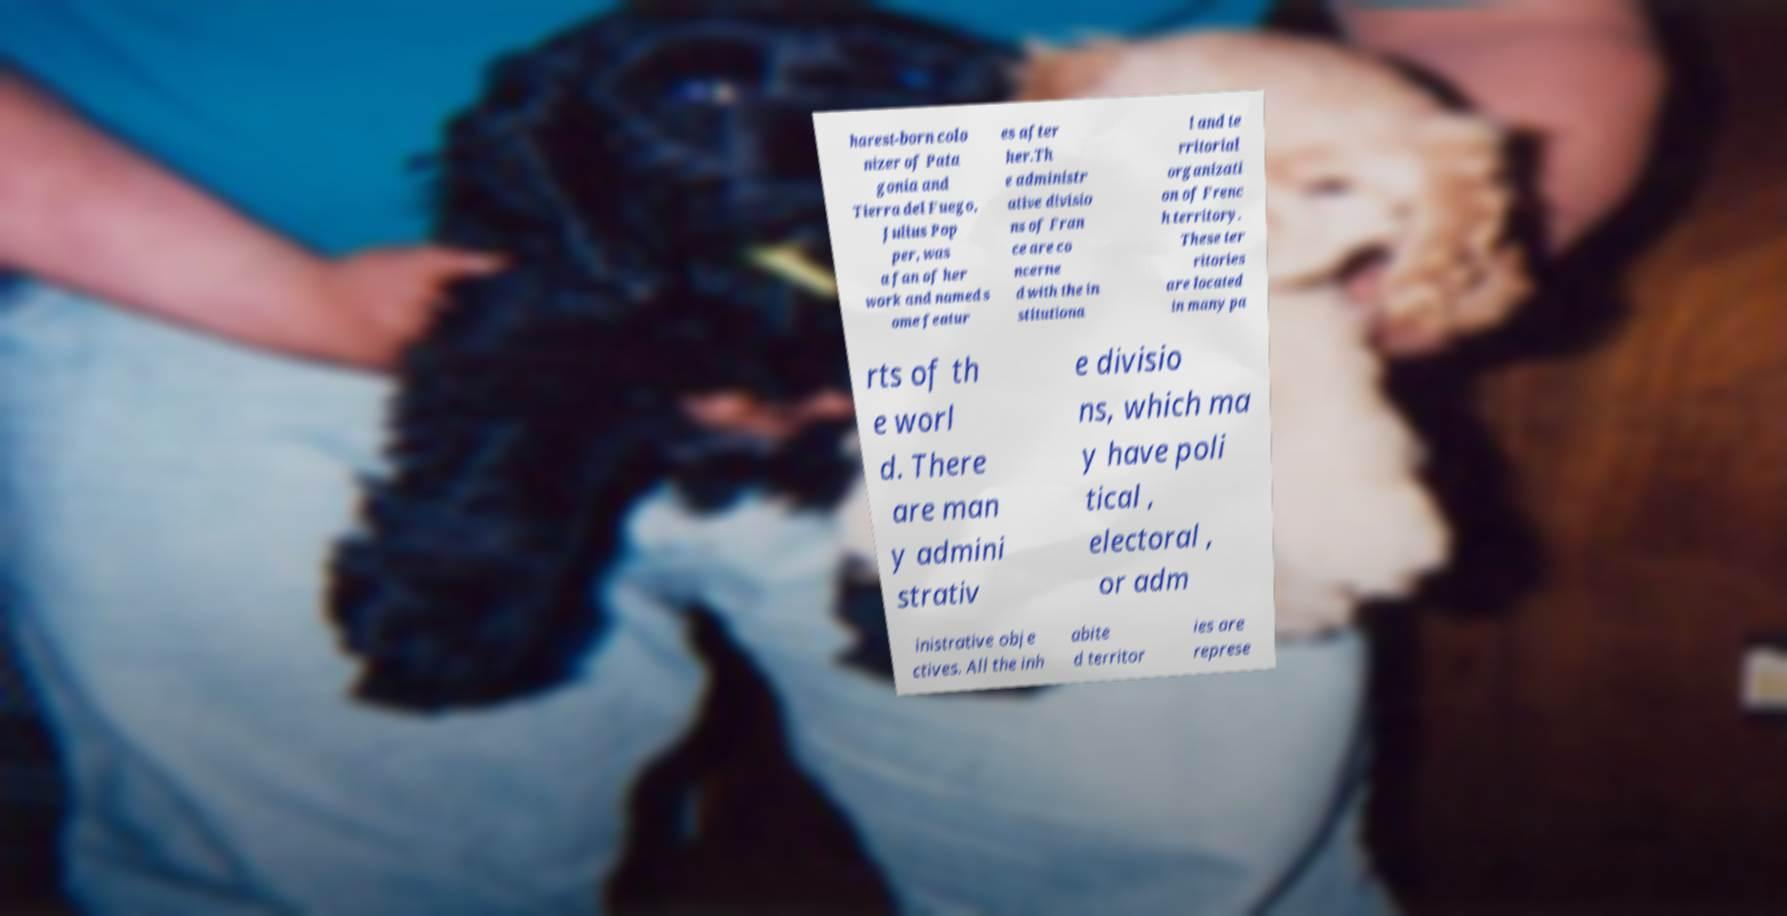Could you extract and type out the text from this image? harest-born colo nizer of Pata gonia and Tierra del Fuego, Julius Pop per, was a fan of her work and named s ome featur es after her.Th e administr ative divisio ns of Fran ce are co ncerne d with the in stitutiona l and te rritorial organizati on of Frenc h territory. These ter ritories are located in many pa rts of th e worl d. There are man y admini strativ e divisio ns, which ma y have poli tical , electoral , or adm inistrative obje ctives. All the inh abite d territor ies are represe 